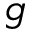Convert formula to latex. <formula><loc_0><loc_0><loc_500><loc_500>g</formula> 